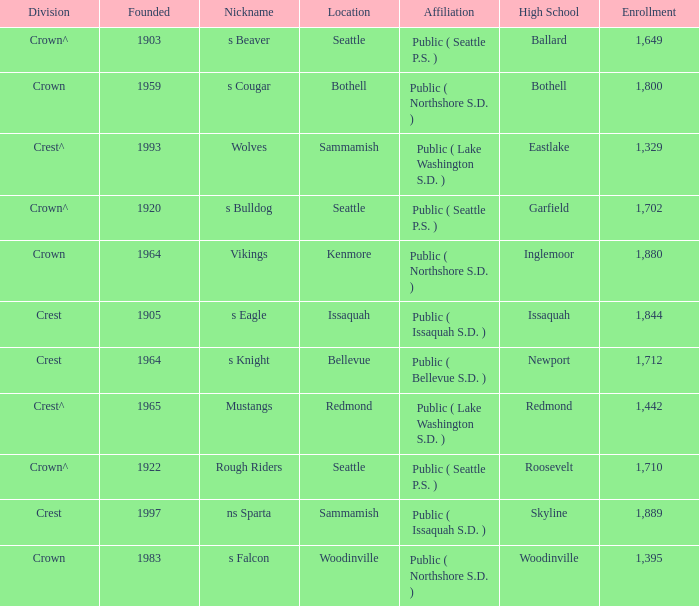What is the affiliation of a location called Issaquah? Public ( Issaquah S.D. ). I'm looking to parse the entire table for insights. Could you assist me with that? {'header': ['Division', 'Founded', 'Nickname', 'Location', 'Affiliation', 'High School', 'Enrollment'], 'rows': [['Crown^', '1903', 's Beaver', 'Seattle', 'Public ( Seattle P.S. )', 'Ballard', '1,649'], ['Crown', '1959', 's Cougar', 'Bothell', 'Public ( Northshore S.D. )', 'Bothell', '1,800'], ['Crest^', '1993', 'Wolves', 'Sammamish', 'Public ( Lake Washington S.D. )', 'Eastlake', '1,329'], ['Crown^', '1920', 's Bulldog', 'Seattle', 'Public ( Seattle P.S. )', 'Garfield', '1,702'], ['Crown', '1964', 'Vikings', 'Kenmore', 'Public ( Northshore S.D. )', 'Inglemoor', '1,880'], ['Crest', '1905', 's Eagle', 'Issaquah', 'Public ( Issaquah S.D. )', 'Issaquah', '1,844'], ['Crest', '1964', 's Knight', 'Bellevue', 'Public ( Bellevue S.D. )', 'Newport', '1,712'], ['Crest^', '1965', 'Mustangs', 'Redmond', 'Public ( Lake Washington S.D. )', 'Redmond', '1,442'], ['Crown^', '1922', 'Rough Riders', 'Seattle', 'Public ( Seattle P.S. )', 'Roosevelt', '1,710'], ['Crest', '1997', 'ns Sparta', 'Sammamish', 'Public ( Issaquah S.D. )', 'Skyline', '1,889'], ['Crown', '1983', 's Falcon', 'Woodinville', 'Public ( Northshore S.D. )', 'Woodinville', '1,395']]} 